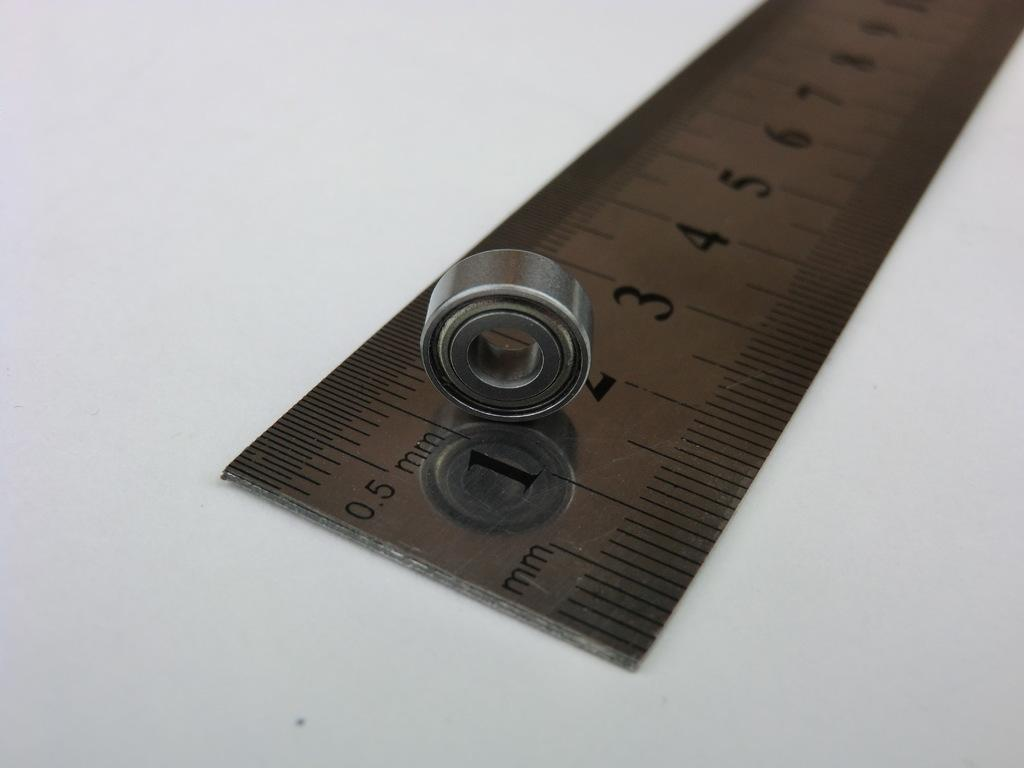What is the main object in the image? There is a scale in the image. Can you describe the shape of the metal object in the image? The metal object in the image is in a circle shape. Can you tell me how many kittens are playing with the skate in the image? There is no skate or kitten present in the image. What type of hammer is shown in the image? There is no hammer present in the image. 